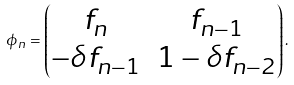Convert formula to latex. <formula><loc_0><loc_0><loc_500><loc_500>\phi _ { n } = \begin{pmatrix} f _ { n } & f _ { n - 1 } \\ - \delta f _ { n - 1 } & 1 - \delta f _ { n - 2 } \end{pmatrix} .</formula> 